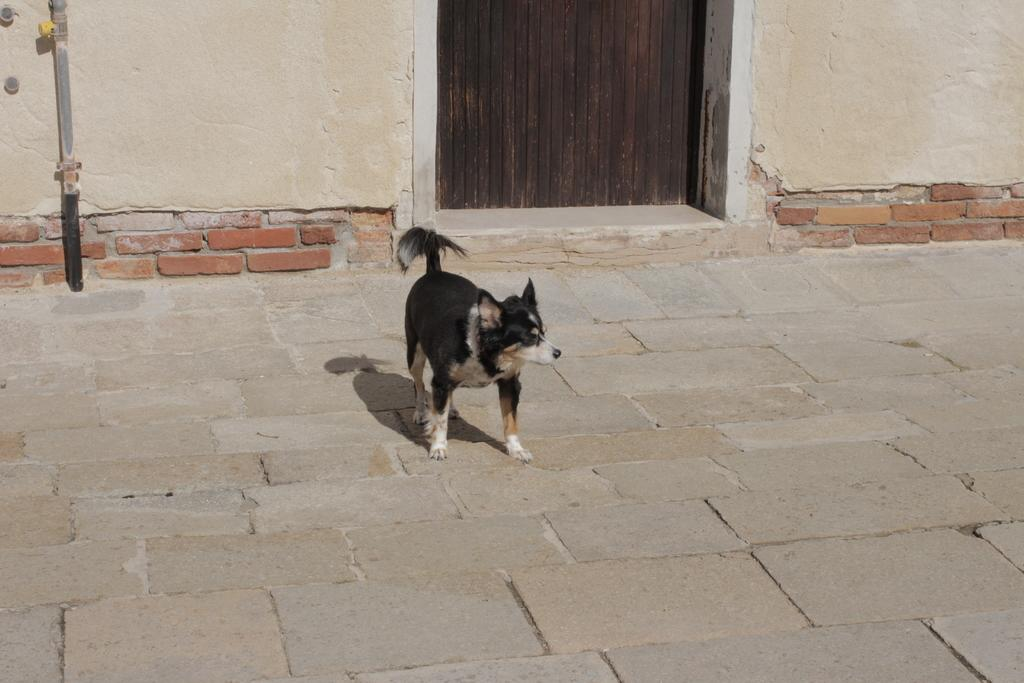What animal can be seen in the image? There is a dog standing in the image. What type of structure is present in the image? There is a wooden door in the image. What vertical object can be seen in the image? There is a pole in the image. What type of architectural feature is present in the image? There are walls in the image. What type of vegetable is being juiced in the image? There is no vegetable or juice present in the image. What sense is the dog using to interact with the wooden door? The provided facts do not mention any interaction between the dog and the wooden door, nor do they mention any sense being used. 